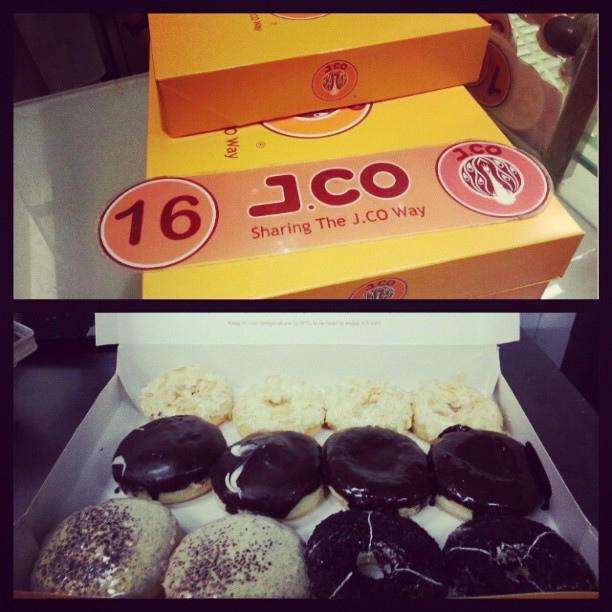What is the Company slogan?
Be succinct. Sharing j co way. What type of dessert is this?
Be succinct. Donut. How donuts are green?
Short answer required. 0. What group does everything in this box belong to?
Give a very brief answer. Donuts. How many of the donuts pictured have holes?
Write a very short answer. 6. 